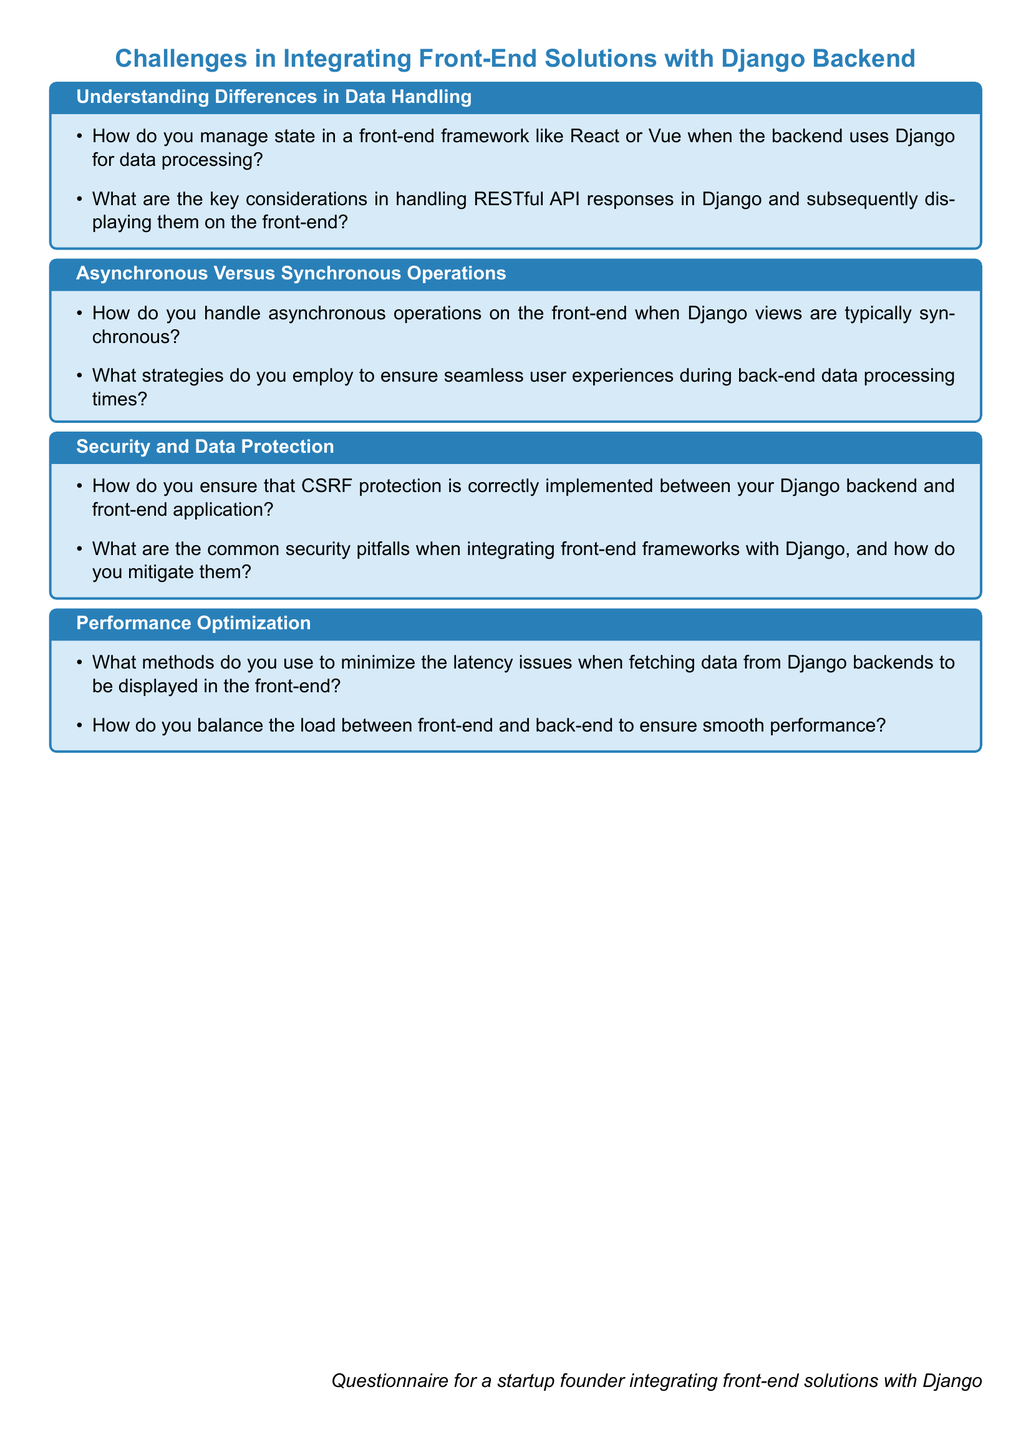What is the title of the questionnaire? The title is prominently displayed at the top of the document, indicating the focus of the questions.
Answer: Challenges in Integrating Front-End Solutions with Django Backend How many sections are in the document? The document contains multiple sections, each addressing specific challenges in integration.
Answer: Four What color is used for the section titles? The color used for section titles is consistent throughout the document.
Answer: Startup What type of operations does the document mention in relation to user experiences? The document discusses the type of operations that are important for smooth interactions with the user interface.
Answer: Asynchronous What is a common security concern mentioned in the document? The document highlights a specific security issue that needs attention during integration efforts.
Answer: CSRF protection What should be minimized to address performance optimization? The document specifies a particular issue that needs to be reduced for better performance.
Answer: Latency issues 